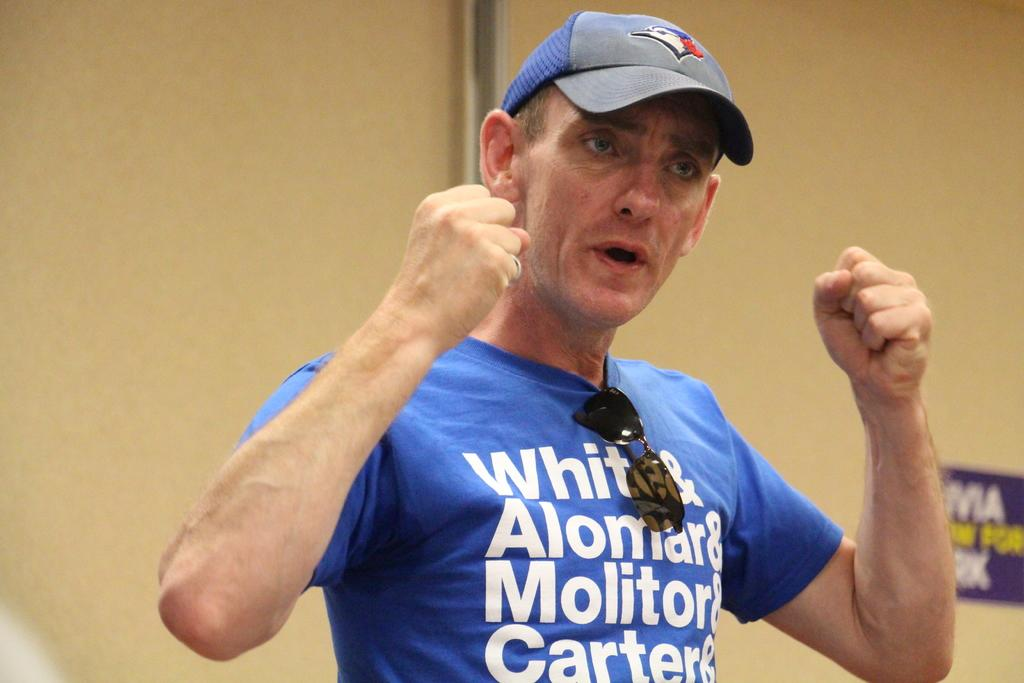<image>
Summarize the visual content of the image. A man holding up his fists with a shirt that say White&Alomar&Molitor&Carter. 